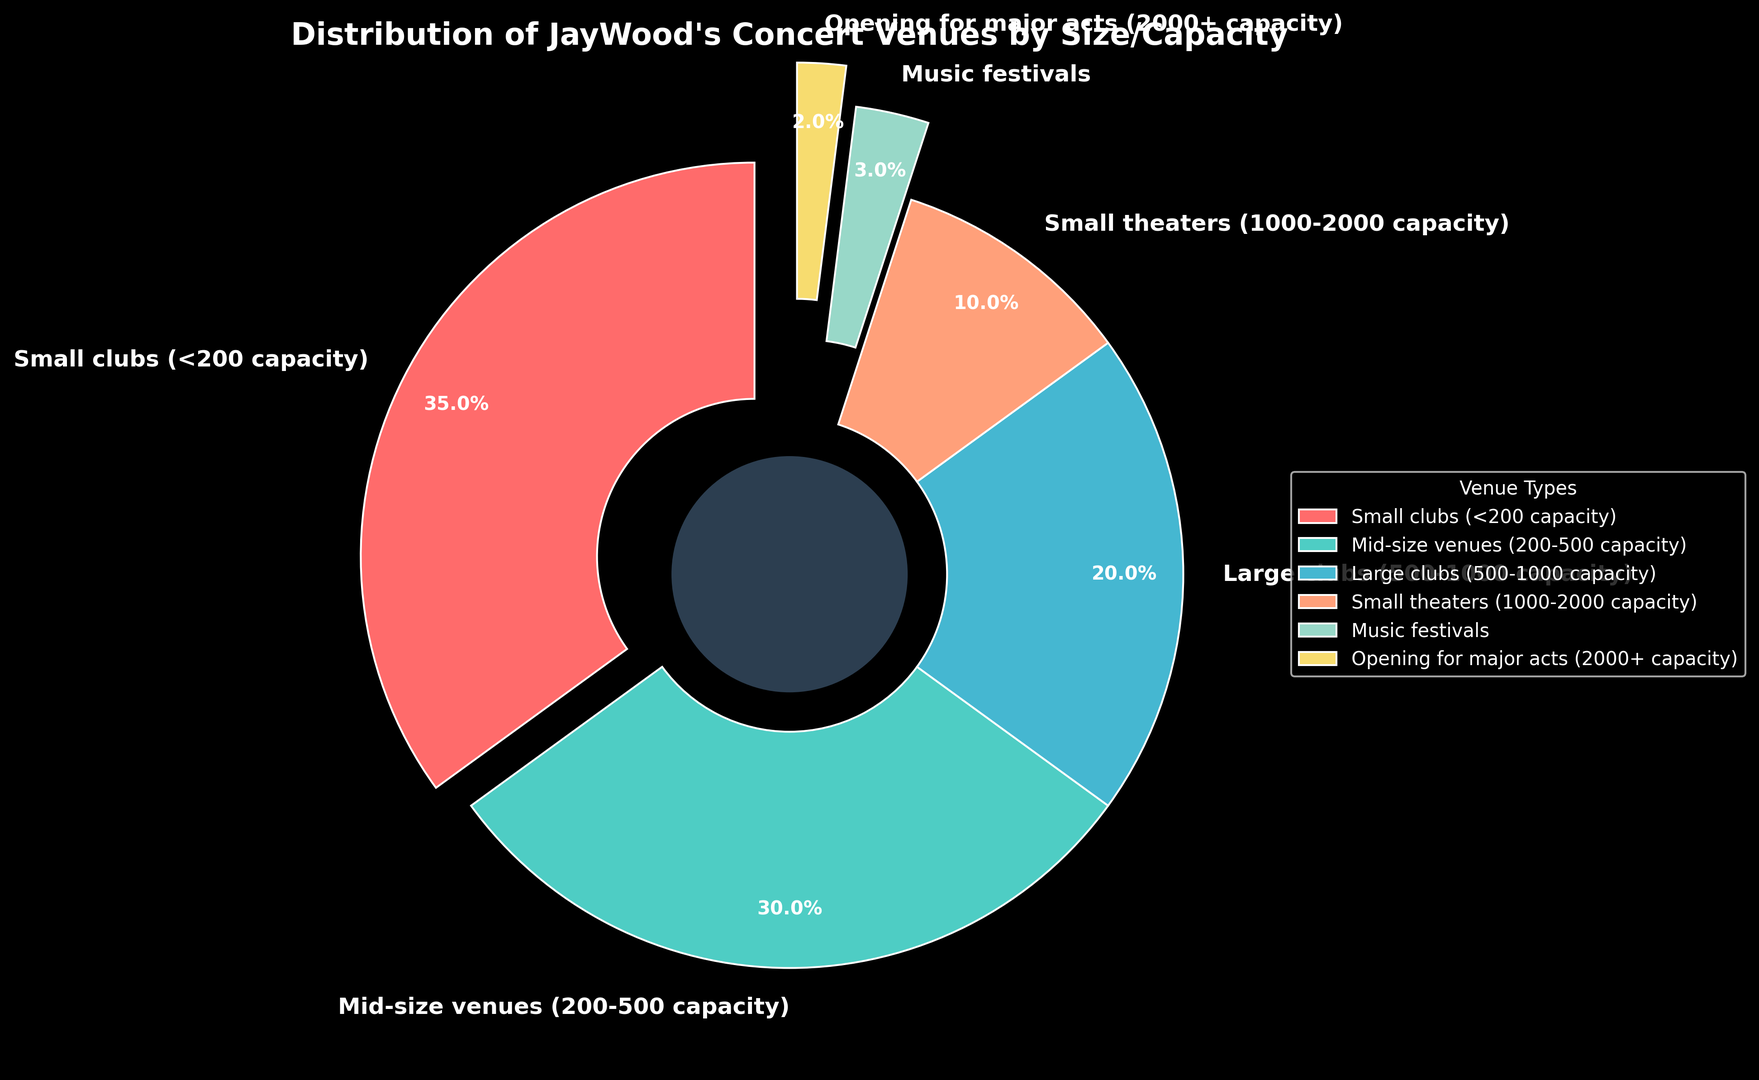Which venue type has the highest percentage of JayWood's concerts? The pie chart shows the percentages for various venue types. The highest percentage is represented by the largest slice, which is "Small clubs (<200 capacity)" at 35%.
Answer: Small clubs (<200 capacity) What is the combined percentage for venue types with a capacity of 500 or less? Summing up the percentages for "Small clubs (<200 capacity)" (35%) and "Mid-size venues (200-500 capacity)" (30%) gives 35 + 30 = 65%.
Answer: 65% How does the percentage for small theaters (1000-2000 capacity) compare to that of music festivals? Comparing the two slices, "Small theaters (1000-2000 capacity)" has 10%, while "Music festivals" has 3%. 10% is greater than 3%.
Answer: Small theaters (1000-2000 capacity) > Music festivals Which slice is the largest non-exploded slice? The "Mid-size venues (200-500 capacity)" slice has the next largest percentage at 30%, and it is not exploded.
Answer: Mid-size venues (200-500 capacity) What is the difference in percentage between large clubs (500-1000 capacity) and opening for major acts? The percentage for "Large clubs (500-1000 capacity)" is 20% and for "Opening for major acts (2000+ capacity)" it is 2%. The difference is 20 - 2 = 18%.
Answer: 18% What percentage of JayWood's concerts take place in venues with more than 1000 capacity? Adding percentages for "Small theaters (1000-2000 capacity)" (10%), "Music festivals" (3%), and "Opening for major acts (2000+ capacity)" (2%) gives 10 + 3 + 2 = 15%.
Answer: 15% Which two venue types have the closest percentages? The "Mid-size venues (200-500 capacity)" at 30% and "Large clubs (500-1000 capacity)" at 20% are the closest in size, with a difference of 10%.
Answer: Mid-size venues (200-500 capacity) and Large clubs (500-1000 capacity) How does the size of the 'Music festivals' slice visually compare to the 'Small clubs (<200 capacity)' slice? The slice for "Music festivals" is much smaller, being represented with only 3%, compared to the "Small clubs (<200 capacity)" slice at 35%.
Answer: Much smaller What visual element highlights the 'Opening for major acts' slice? The 'Opening for major acts' slice is visually highlighted by it being exploded outwards the most, and also occurs at the bottom left of the chart.
Answer: Exploded outwards 